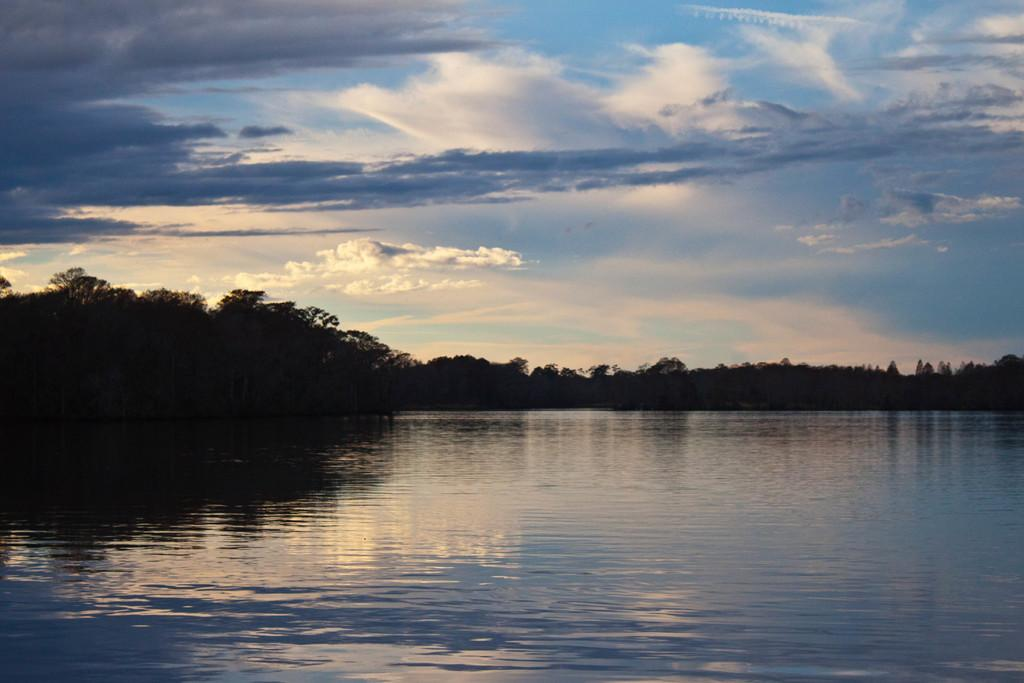What type of natural feature is present in the image? There is a river in the image. What other natural elements can be seen in the image? There are trees in the image. What is visible in the background of the image? The sky is visible in the image. What type of appliance is floating in the river in the image? There is no appliance present in the image; it only features a river, trees, and the sky. 